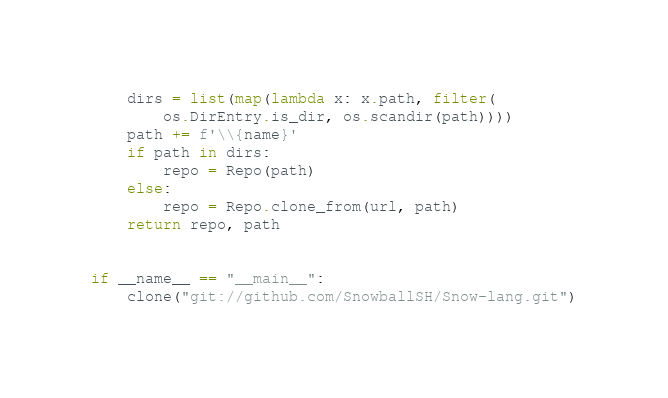Convert code to text. <code><loc_0><loc_0><loc_500><loc_500><_Python_>    dirs = list(map(lambda x: x.path, filter(
        os.DirEntry.is_dir, os.scandir(path))))
    path += f'\\{name}'
    if path in dirs:
        repo = Repo(path)
    else:
        repo = Repo.clone_from(url, path)
    return repo, path


if __name__ == "__main__":
    clone("git://github.com/SnowballSH/Snow-lang.git")
</code> 